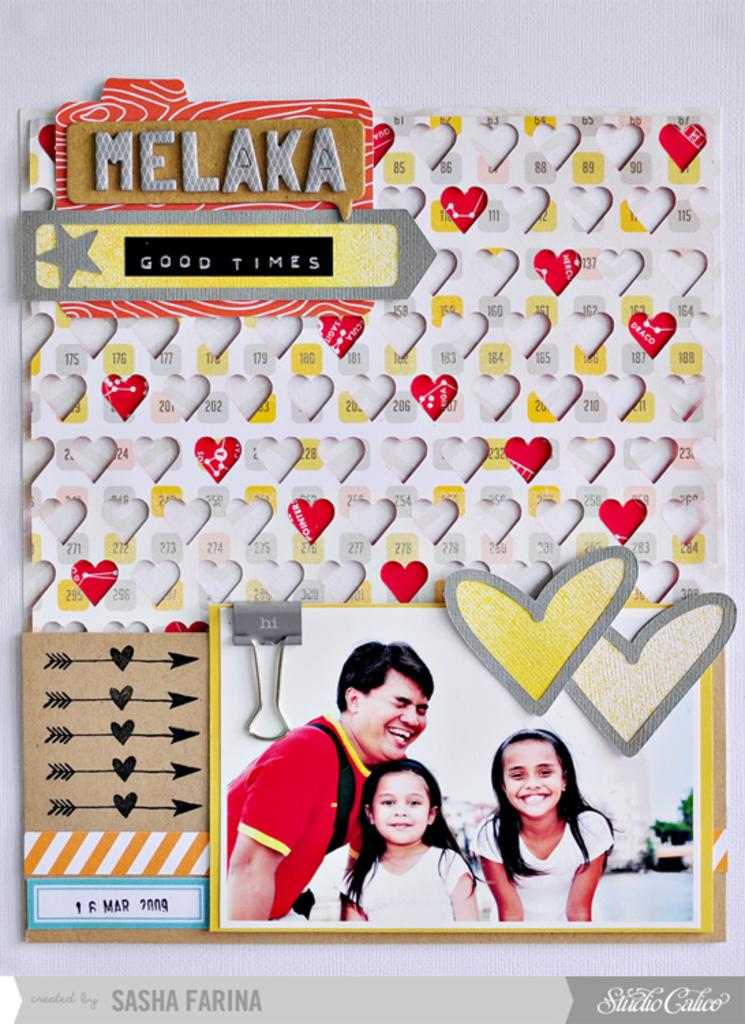What is present in the image that contains images and symbols? There is a poster in the image that contains images of people and symbols. Can you describe the images on the poster? The images on the poster contain representations of people. What else can be found on the poster besides the images? The poster also contains symbols. What color is the sock on the person's neck in the image? There is no sock or person present in the image; it only contains a poster with images of people and symbols. 